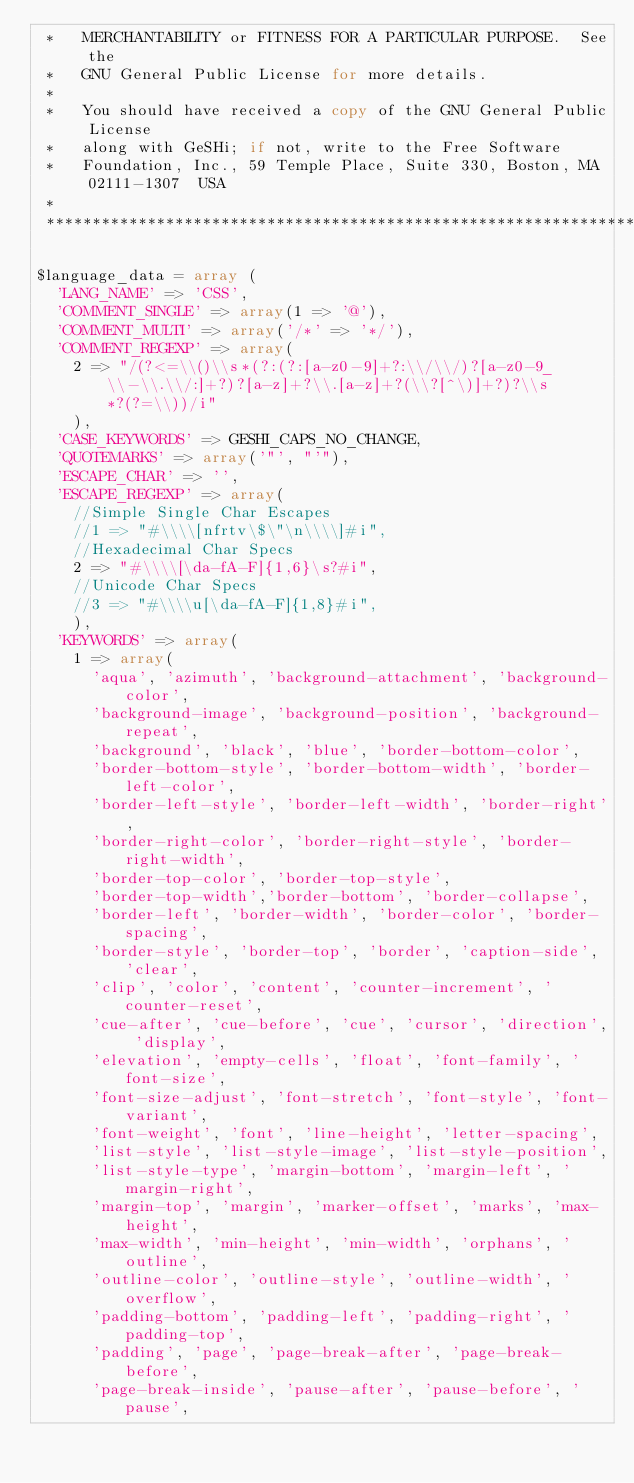<code> <loc_0><loc_0><loc_500><loc_500><_PHP_> *   MERCHANTABILITY or FITNESS FOR A PARTICULAR PURPOSE.  See the
 *   GNU General Public License for more details.
 *
 *   You should have received a copy of the GNU General Public License
 *   along with GeSHi; if not, write to the Free Software
 *   Foundation, Inc., 59 Temple Place, Suite 330, Boston, MA  02111-1307  USA
 *
 ************************************************************************************/

$language_data = array (
	'LANG_NAME' => 'CSS',
	'COMMENT_SINGLE' => array(1 => '@'),
	'COMMENT_MULTI' => array('/*' => '*/'),
	'COMMENT_REGEXP' => array(
		2 => "/(?<=\\()\\s*(?:(?:[a-z0-9]+?:\\/\\/)?[a-z0-9_\\-\\.\\/:]+?)?[a-z]+?\\.[a-z]+?(\\?[^\)]+?)?\\s*?(?=\\))/i"
		),
	'CASE_KEYWORDS' => GESHI_CAPS_NO_CHANGE,
	'QUOTEMARKS' => array('"', "'"),
	'ESCAPE_CHAR' => '',
	'ESCAPE_REGEXP' => array(
		//Simple Single Char Escapes
		//1 => "#\\\\[nfrtv\$\"\n\\\\]#i",
		//Hexadecimal Char Specs
		2 => "#\\\\[\da-fA-F]{1,6}\s?#i",
		//Unicode Char Specs
		//3 => "#\\\\u[\da-fA-F]{1,8}#i",
		),
	'KEYWORDS' => array(
		1 => array(
			'aqua', 'azimuth', 'background-attachment', 'background-color',
			'background-image', 'background-position', 'background-repeat',
			'background', 'black', 'blue', 'border-bottom-color',
			'border-bottom-style', 'border-bottom-width', 'border-left-color',
			'border-left-style', 'border-left-width', 'border-right',
			'border-right-color', 'border-right-style', 'border-right-width',
			'border-top-color', 'border-top-style',
			'border-top-width','border-bottom', 'border-collapse',
			'border-left', 'border-width', 'border-color', 'border-spacing',
			'border-style', 'border-top', 'border', 'caption-side', 'clear',
			'clip', 'color', 'content', 'counter-increment', 'counter-reset',
			'cue-after', 'cue-before', 'cue', 'cursor', 'direction', 'display',
			'elevation', 'empty-cells', 'float', 'font-family', 'font-size',
			'font-size-adjust', 'font-stretch', 'font-style', 'font-variant',
			'font-weight', 'font', 'line-height', 'letter-spacing',
			'list-style', 'list-style-image', 'list-style-position',
			'list-style-type', 'margin-bottom', 'margin-left', 'margin-right',
			'margin-top', 'margin', 'marker-offset', 'marks', 'max-height',
			'max-width', 'min-height', 'min-width', 'orphans', 'outline',
			'outline-color', 'outline-style', 'outline-width', 'overflow',
			'padding-bottom', 'padding-left', 'padding-right', 'padding-top',
			'padding', 'page', 'page-break-after', 'page-break-before',
			'page-break-inside', 'pause-after', 'pause-before', 'pause',</code> 